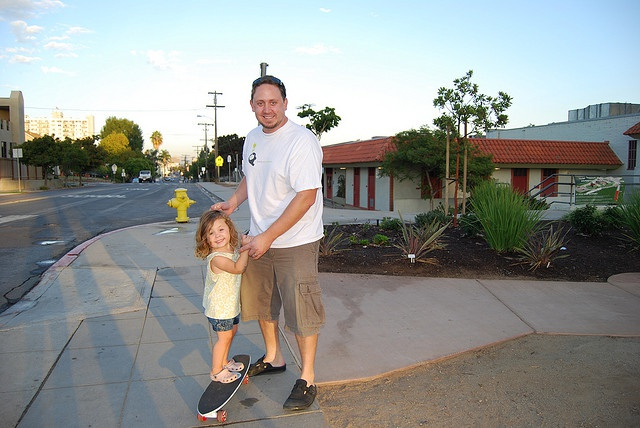Describe the objects in this image and their specific colors. I can see people in lightgray, gray, and tan tones, people in lightgray, khaki, tan, and beige tones, skateboard in lightgray, black, gray, and ivory tones, fire hydrant in lightgray, gold, olive, and khaki tones, and car in lightgray, black, gray, and darkgray tones in this image. 